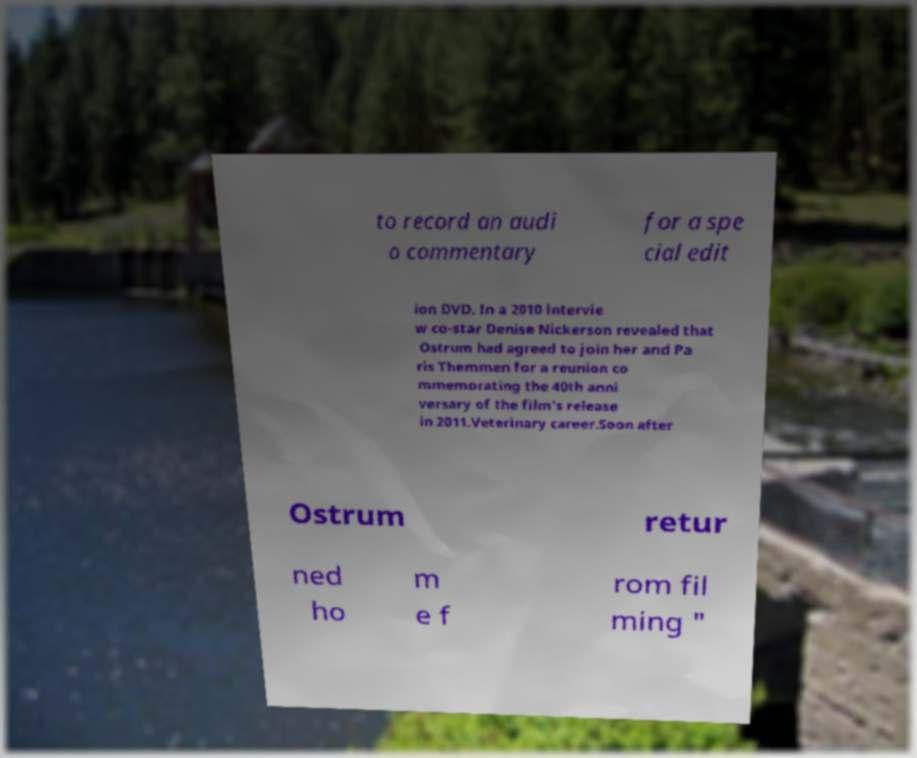Could you extract and type out the text from this image? to record an audi o commentary for a spe cial edit ion DVD. In a 2010 intervie w co-star Denise Nickerson revealed that Ostrum had agreed to join her and Pa ris Themmen for a reunion co mmemorating the 40th anni versary of the film's release in 2011.Veterinary career.Soon after Ostrum retur ned ho m e f rom fil ming " 